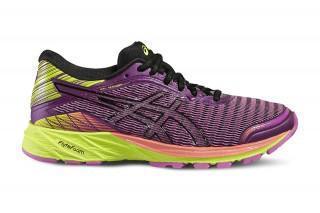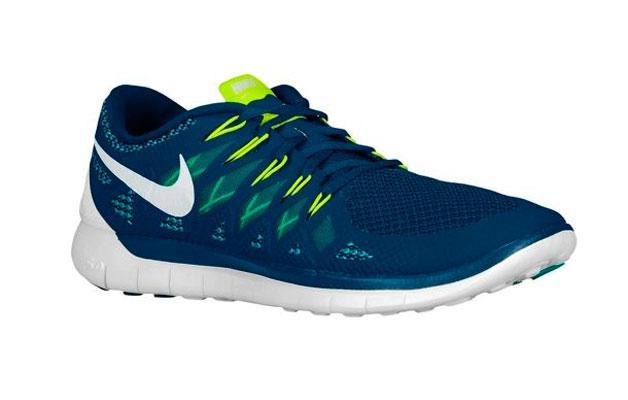The first image is the image on the left, the second image is the image on the right. For the images displayed, is the sentence "There is exactly three tennis shoes." factually correct? Answer yes or no. No. The first image is the image on the left, the second image is the image on the right. Evaluate the accuracy of this statement regarding the images: "The left image shows a pair of sneakers with one of the sneakers resting partially atop the other". Is it true? Answer yes or no. No. 